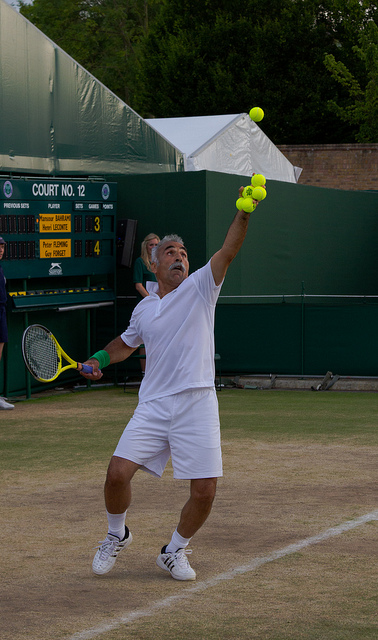Read and extract the text from this image. COURT NO. 12 4 3 